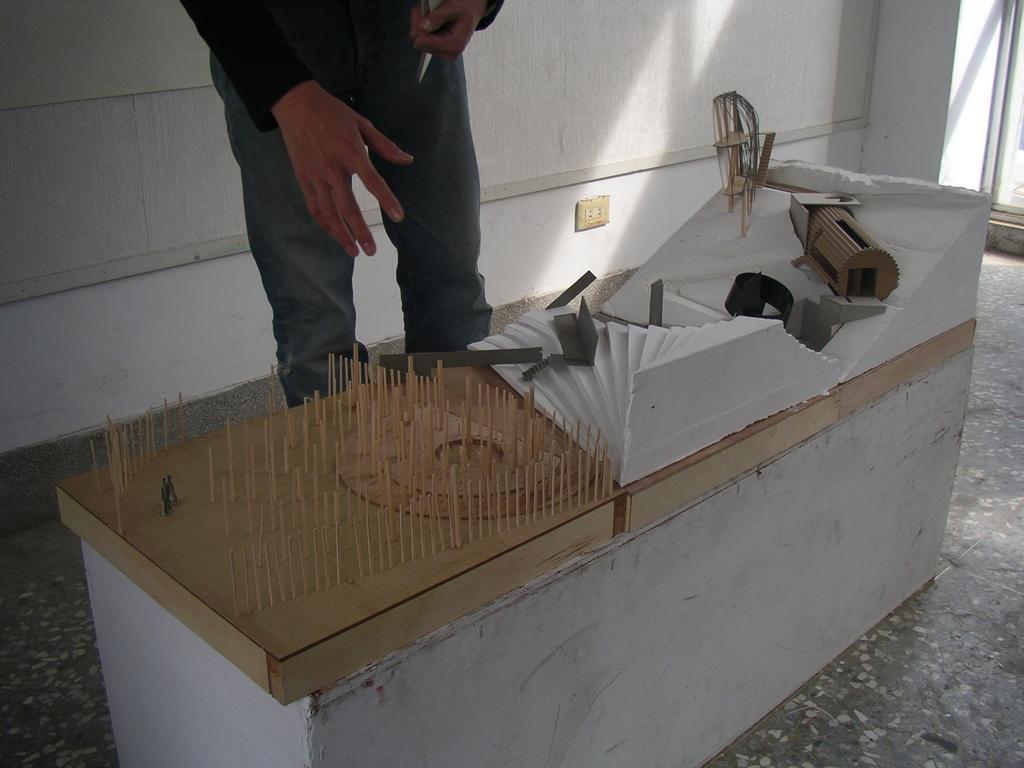In one or two sentences, can you explain what this image depicts? There is a person in standing. In front of him, there are some tools on the table. In the background, there is a plug board on the wall which is in white color. 